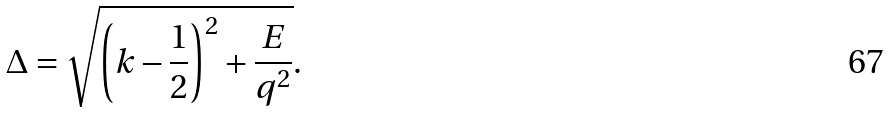<formula> <loc_0><loc_0><loc_500><loc_500>\Delta = \sqrt { \left ( k - \frac { 1 } { 2 } \right ) ^ { 2 } + \frac { E } { q ^ { 2 } } } .</formula> 